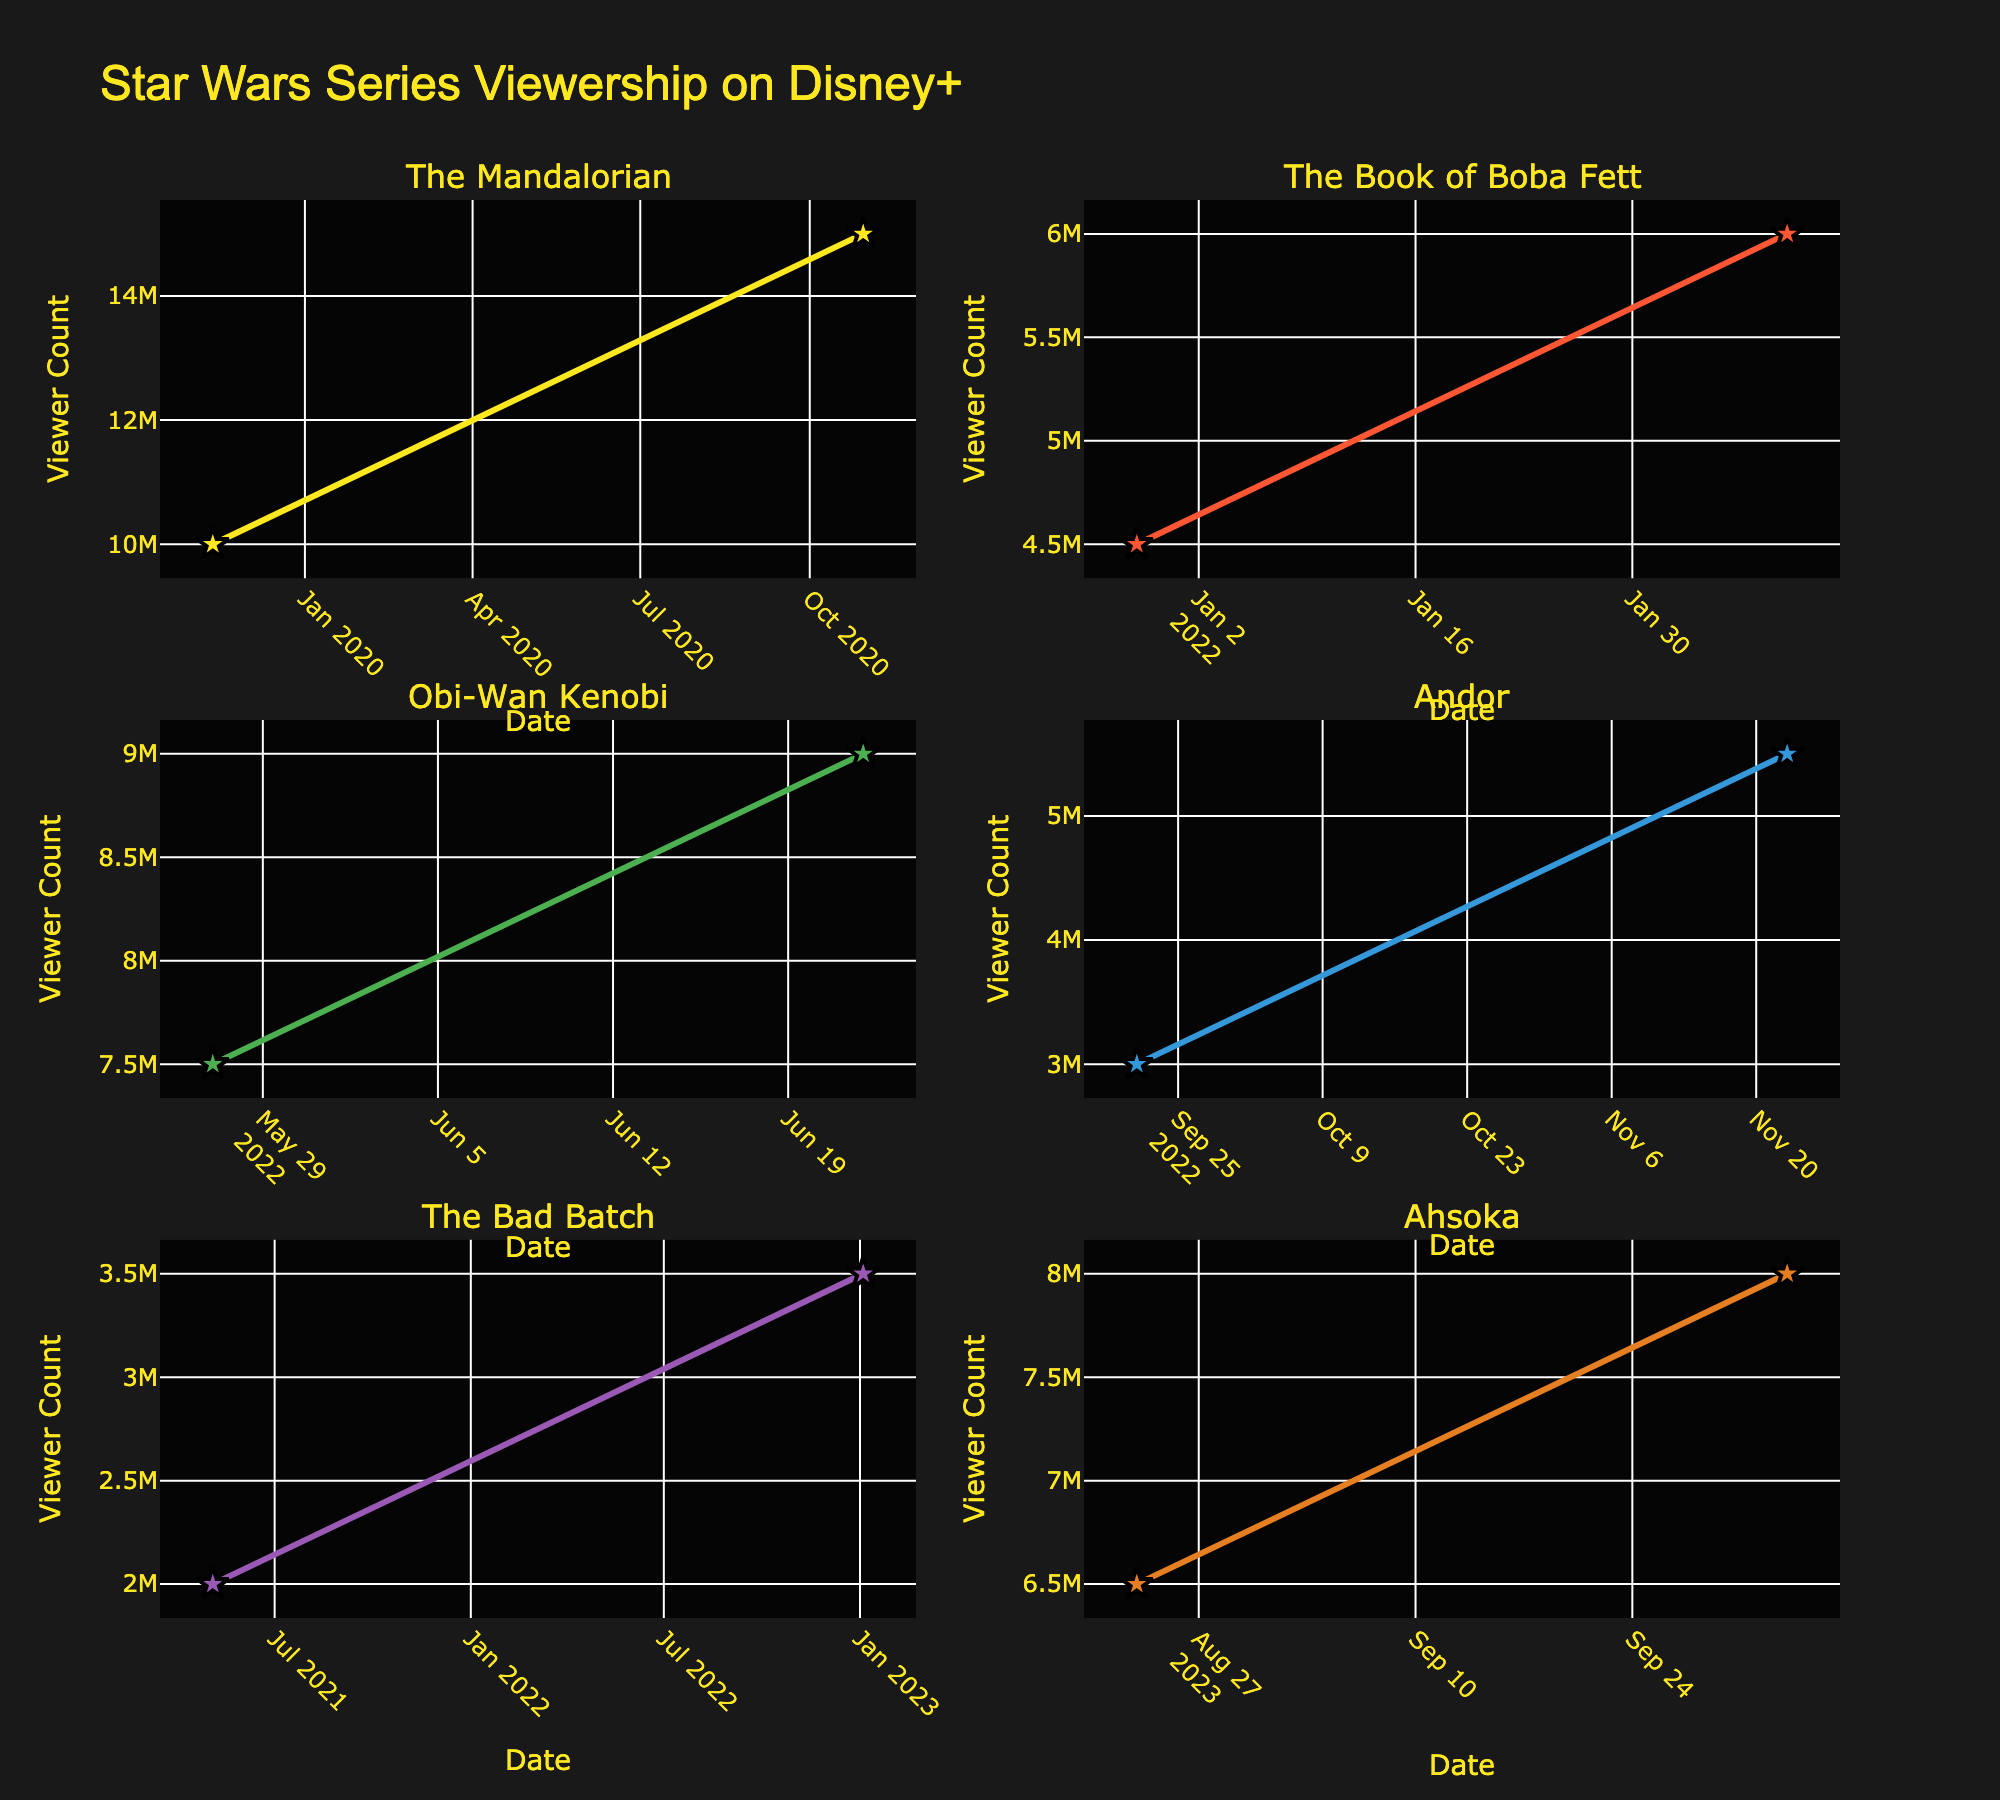How many series have their own subplot in the figure? Look at the number of subplot titles in the figure. Each subplot corresponds to a different series.
Answer: 6 What is the highest viewer count for "The Mandalorian"? Locate "The Mandalorian" subplot and identify the highest point on the y-axis (viewer count).
Answer: 15,000,000 Which series had the lowest viewer count at any given point in time? Compare the lowest data points in each subplot to find the minimum.
Answer: The Bad Batch On what date did "Obi-Wan Kenobi" reach its peak viewership? Check the "Obi-Wan Kenobi" subplot and find the date corresponding to the highest viewer count.
Answer: 2022-06-22 How much did the viewership of "The Book of Boba Fett" increase from its initial release to its peak? Find the difference in viewer counts between the initial data point and the peak data point in "The Book of Boba Fett" subplot.
Answer: 1,500,000 Which series had the largest increase in viewership and how much was it? Compare the increases in viewership between the data points for each series and identify the largest.
Answer: The Mandalorian, 5,000,000 What was the average viewer count for "Andor" across its observed time points? Add the viewer counts for "Andor" and divide by the number of data points. \( \frac{3,000,000 + 5,500,000}{2} = 4,250,000 \)
Answer: 4,250,000 Which series has the most scattered viewership data points over time? Look at the series that has more points scattered across the x-axis (dates).
Answer: Ahsoka Did any series show a decrease in viewership over time? If so, which one? Check each series' subplot to see if any lines/points indicate a decrease in viewership over any time span.
Answer: No series showed a decreasing trend Between "Ahsoka" and "Obi-Wan Kenobi," which had a higher viewership on their peak dates? Compare the peak data points of "Ahsoka" and "Obi-Wan Kenobi" subplots.
Answer: Obi-Wan Kenobi 